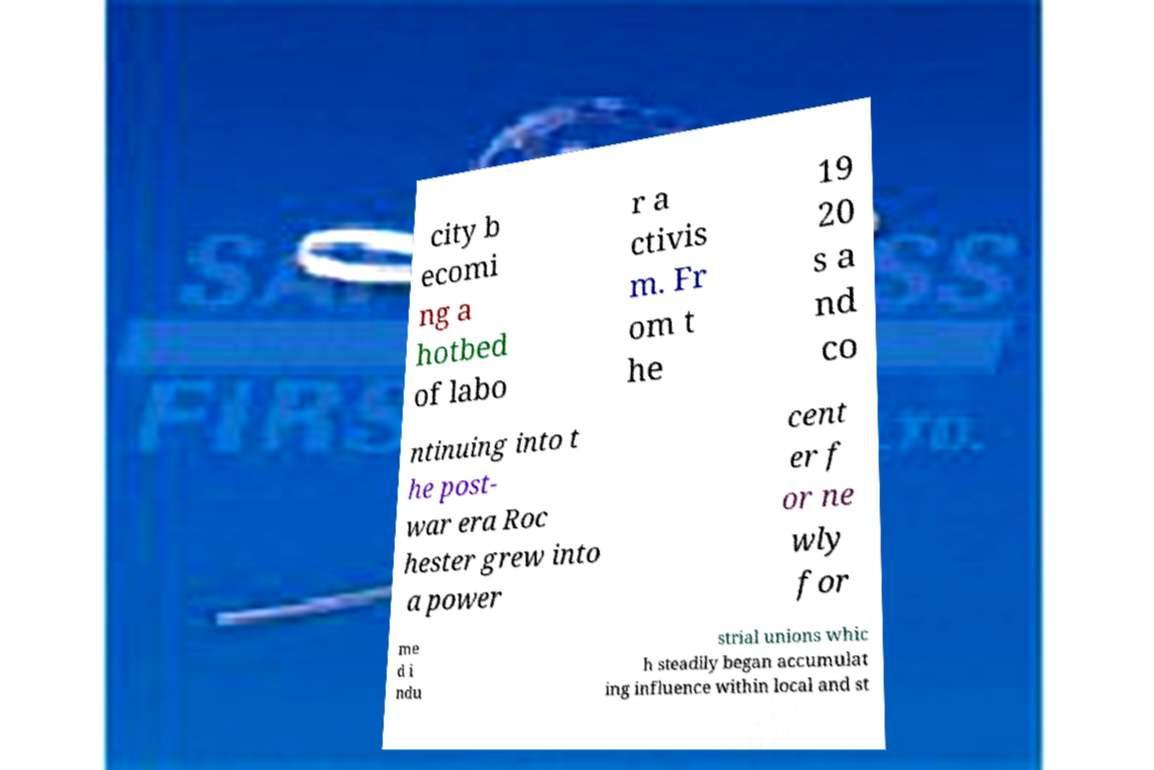Please read and relay the text visible in this image. What does it say? city b ecomi ng a hotbed of labo r a ctivis m. Fr om t he 19 20 s a nd co ntinuing into t he post- war era Roc hester grew into a power cent er f or ne wly for me d i ndu strial unions whic h steadily began accumulat ing influence within local and st 